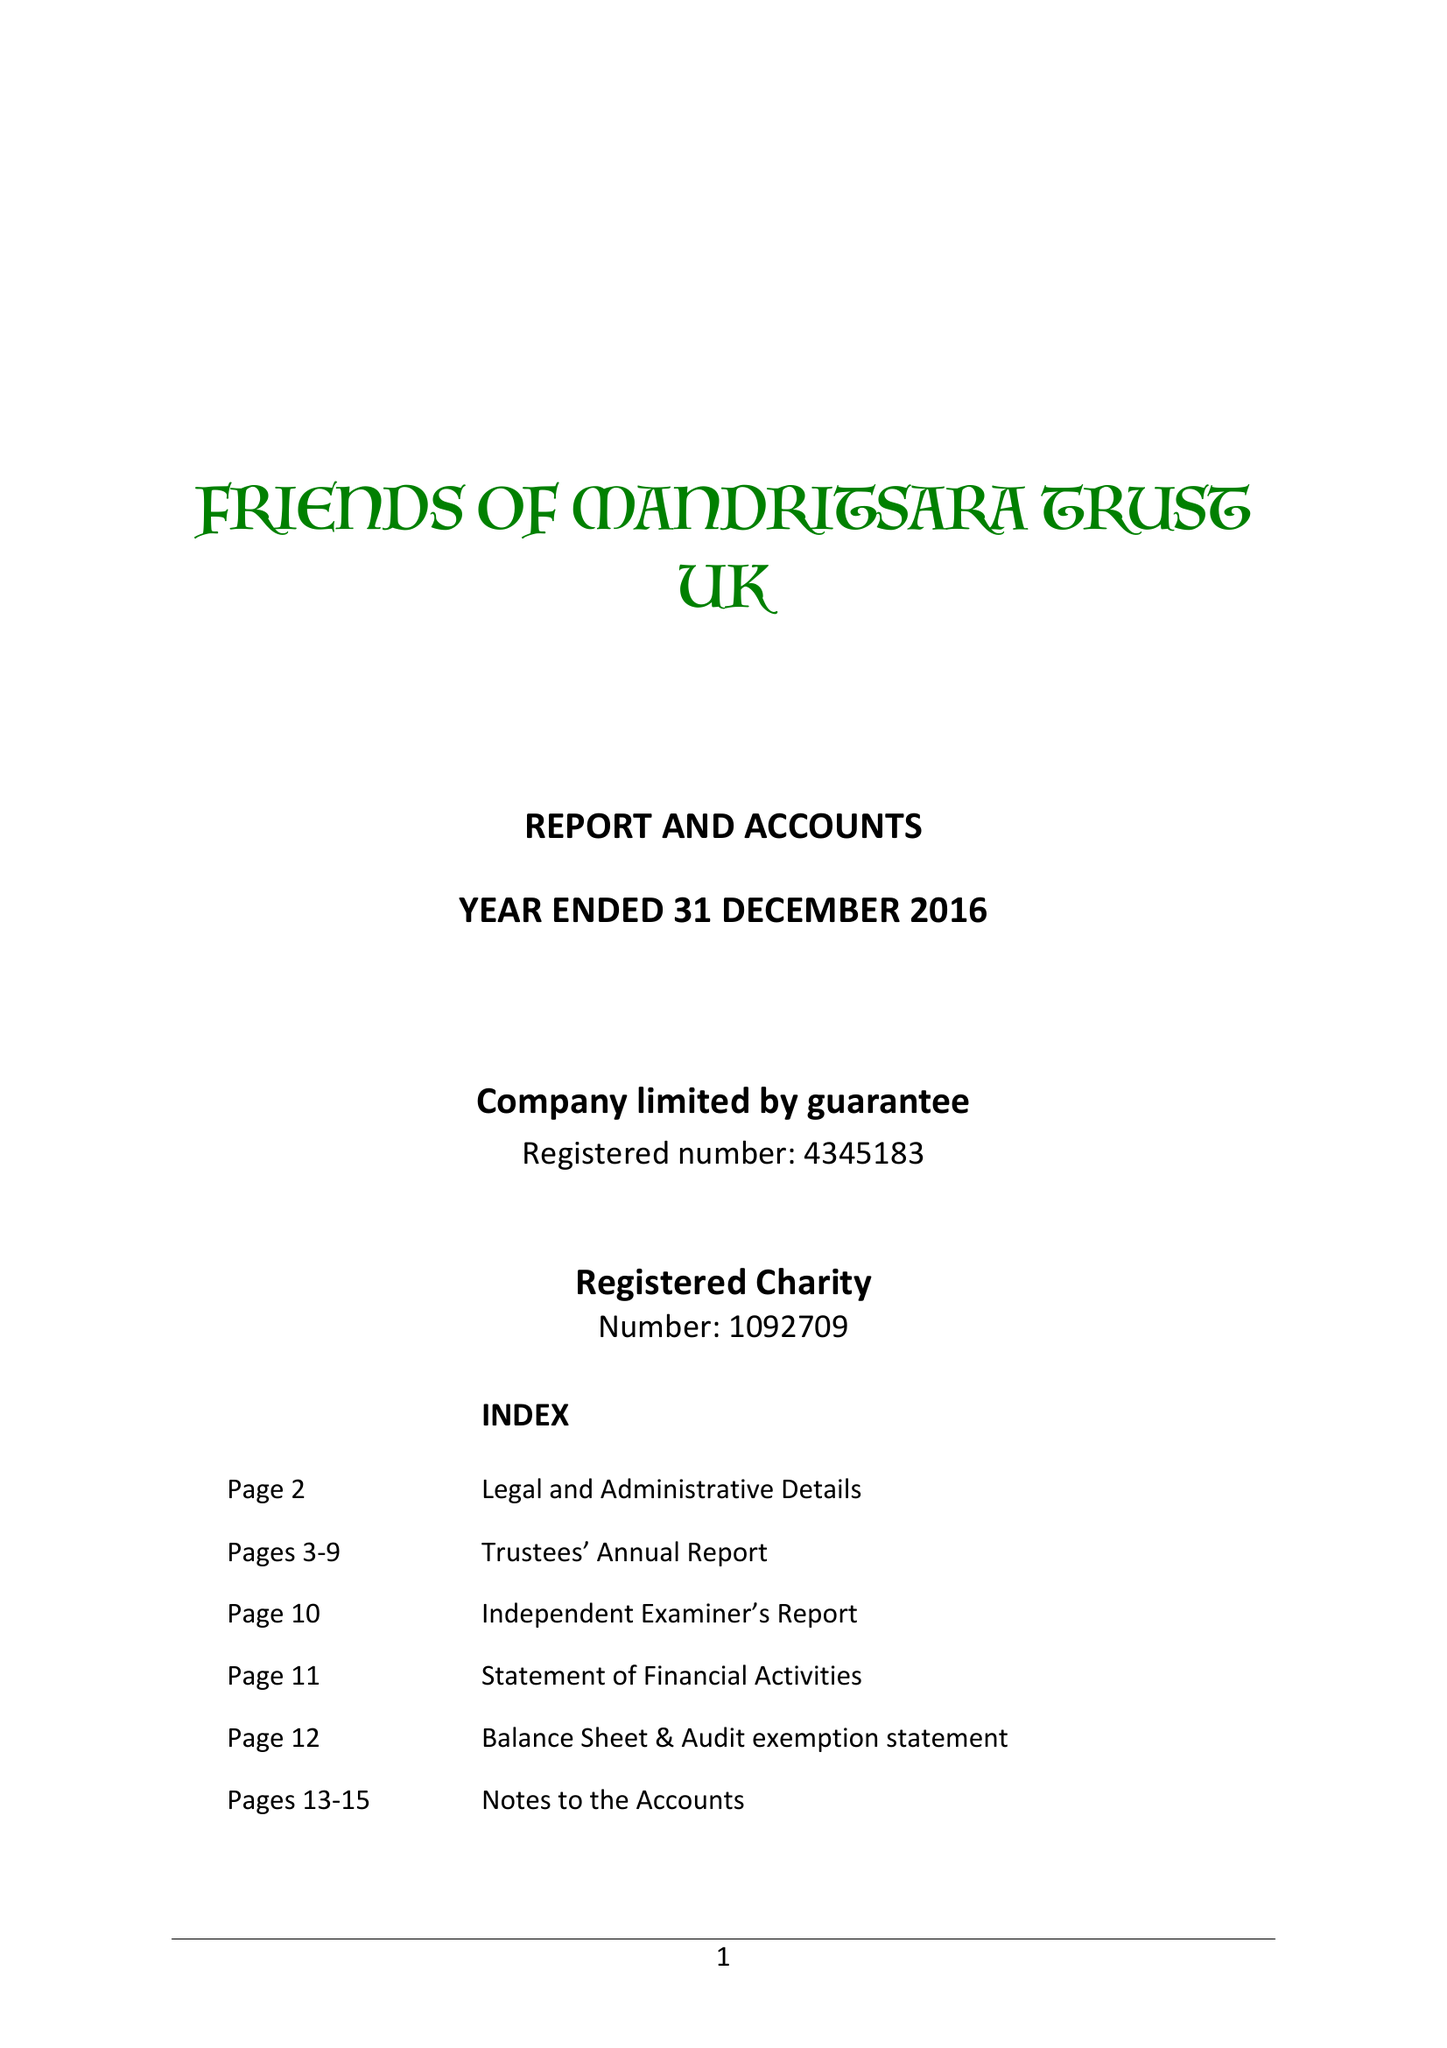What is the value for the address__post_town?
Answer the question using a single word or phrase. ST. IVES 